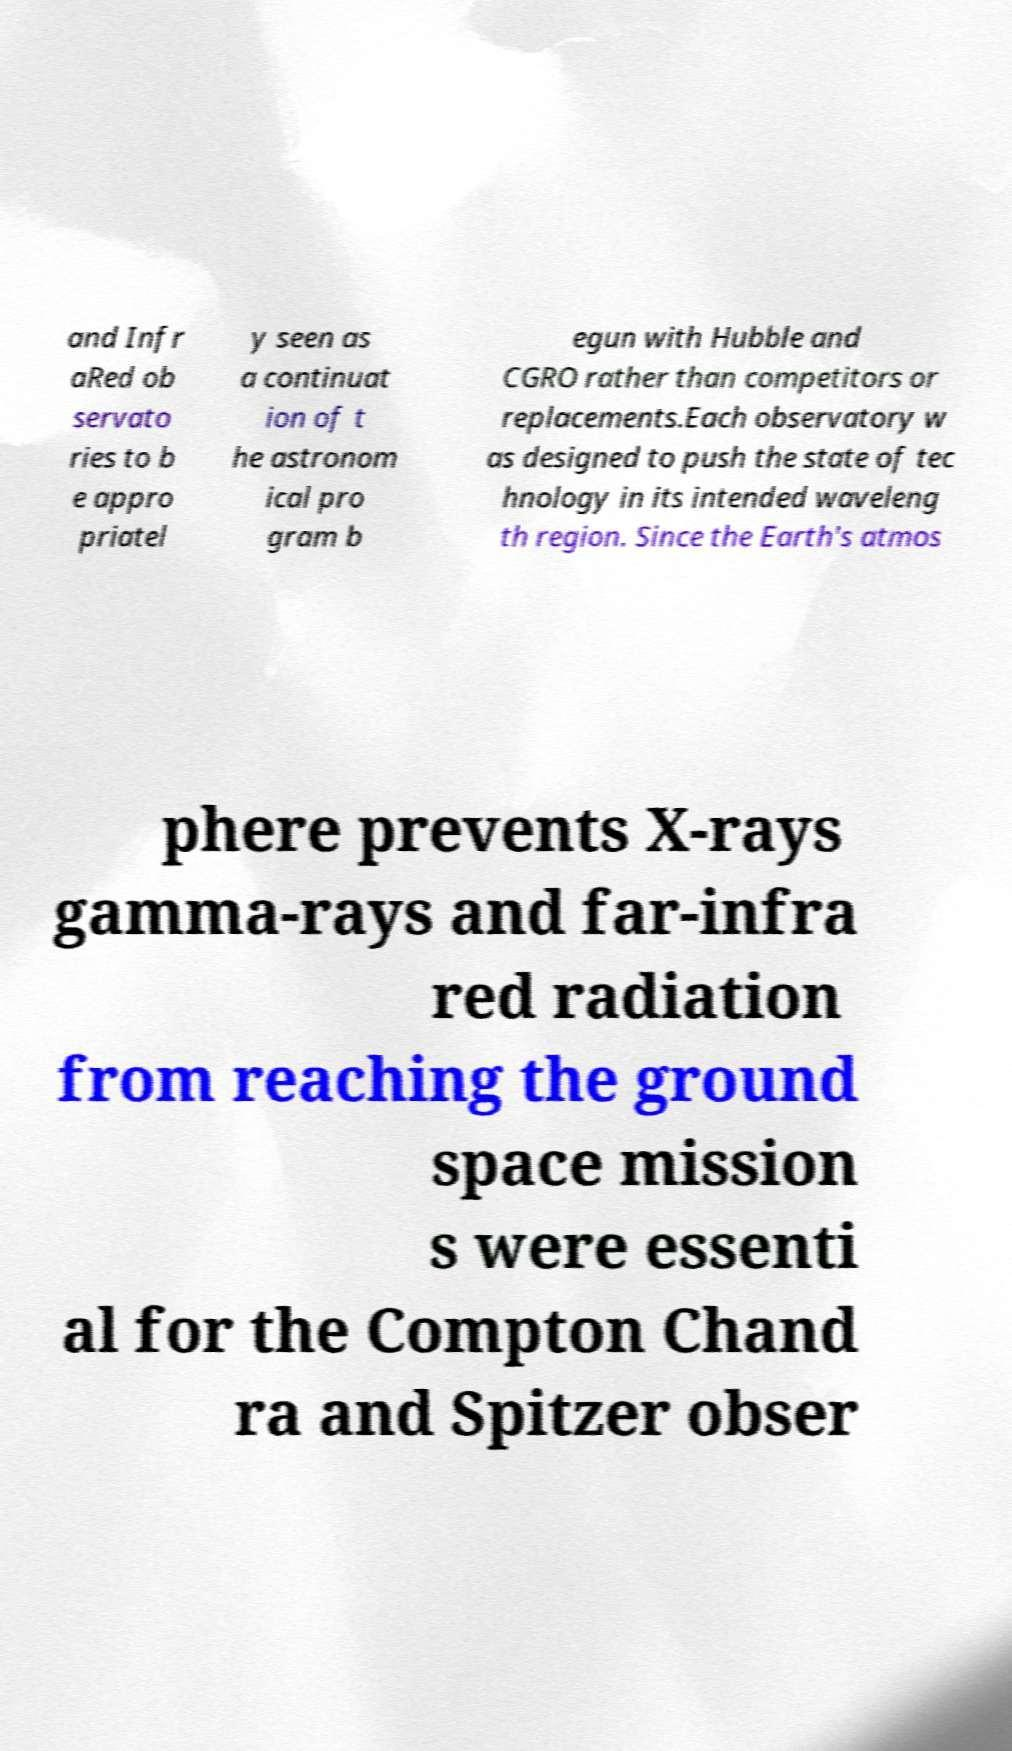Could you extract and type out the text from this image? and Infr aRed ob servato ries to b e appro priatel y seen as a continuat ion of t he astronom ical pro gram b egun with Hubble and CGRO rather than competitors or replacements.Each observatory w as designed to push the state of tec hnology in its intended waveleng th region. Since the Earth's atmos phere prevents X-rays gamma-rays and far-infra red radiation from reaching the ground space mission s were essenti al for the Compton Chand ra and Spitzer obser 